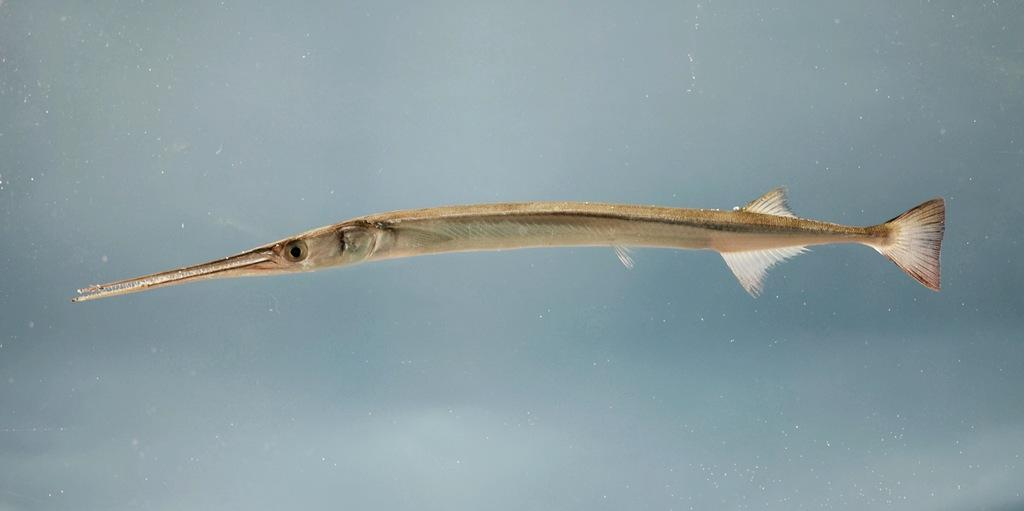What type of animal is in the image? There is a fish in the image. Where is the fish located? The fish is in the water. How does the fish help to carry the crate in the image? There is no crate present in the image, and the fish is not helping to carry anything. 